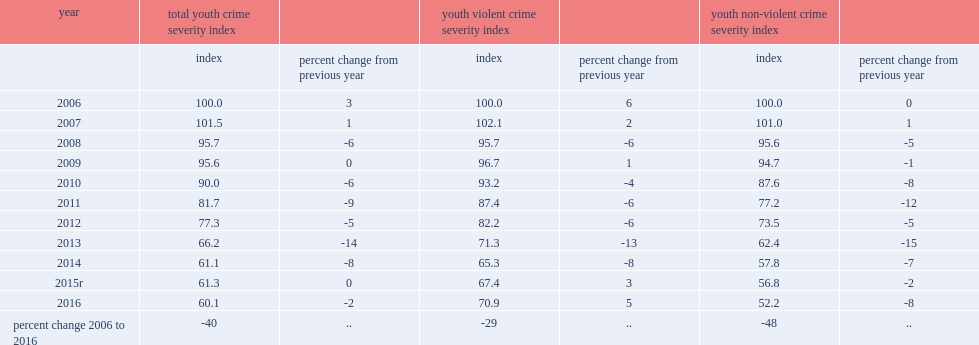Comparing to previous year, how many percentage point of the youth crime severity index has declined in 2016? 2. Comparing to previous year, how many percentage point of the youth-violent csi has declined in 2016? 8. Comparing to 2015, how many percentage point of the youth-violent csi has increased in 2016? 5.0. 